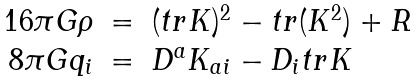Convert formula to latex. <formula><loc_0><loc_0><loc_500><loc_500>\begin{array} { r c l } 1 6 \pi G \rho & = & ( t r K ) ^ { 2 } - t r ( K ^ { 2 } ) + R \\ 8 \pi G q _ { i } & = & D ^ { a } K _ { a i } - D _ { i } t r K \end{array}</formula> 